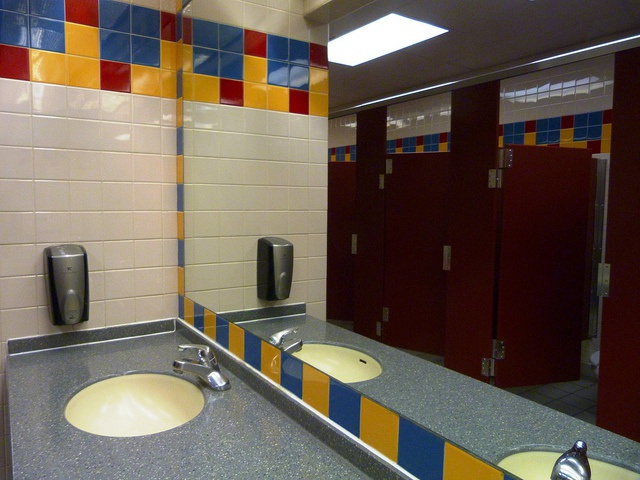Describe the objects in this image and their specific colors. I can see sink in navy, khaki, beige, tan, and darkgray tones, sink in navy, khaki, tan, and gray tones, sink in navy, khaki, and tan tones, and toilet in navy, gray, and black tones in this image. 